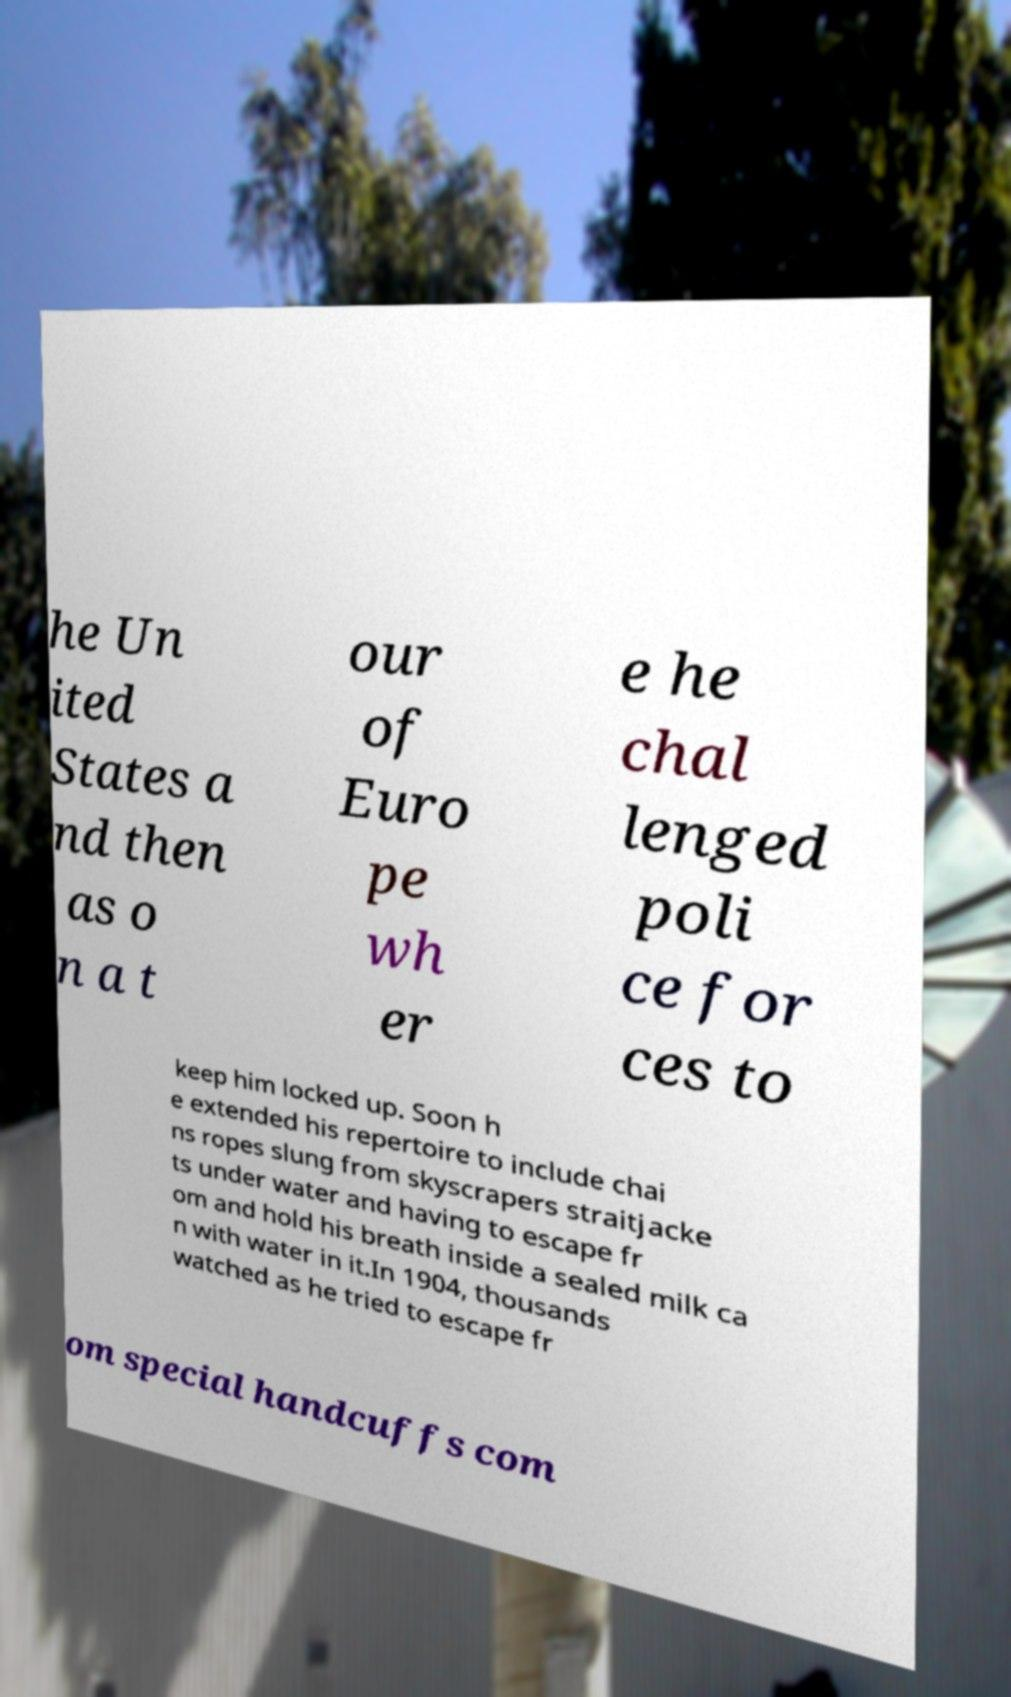I need the written content from this picture converted into text. Can you do that? he Un ited States a nd then as o n a t our of Euro pe wh er e he chal lenged poli ce for ces to keep him locked up. Soon h e extended his repertoire to include chai ns ropes slung from skyscrapers straitjacke ts under water and having to escape fr om and hold his breath inside a sealed milk ca n with water in it.In 1904, thousands watched as he tried to escape fr om special handcuffs com 